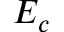Convert formula to latex. <formula><loc_0><loc_0><loc_500><loc_500>E _ { c }</formula> 